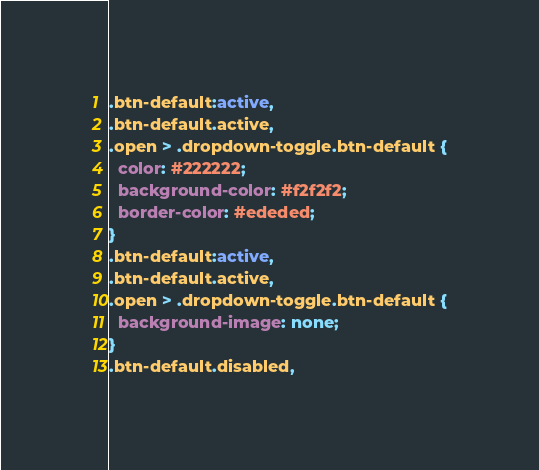<code> <loc_0><loc_0><loc_500><loc_500><_CSS_>.btn-default:active,
.btn-default.active,
.open > .dropdown-toggle.btn-default {
  color: #222222;
  background-color: #f2f2f2;
  border-color: #ededed;
}
.btn-default:active,
.btn-default.active,
.open > .dropdown-toggle.btn-default {
  background-image: none;
}
.btn-default.disabled,</code> 